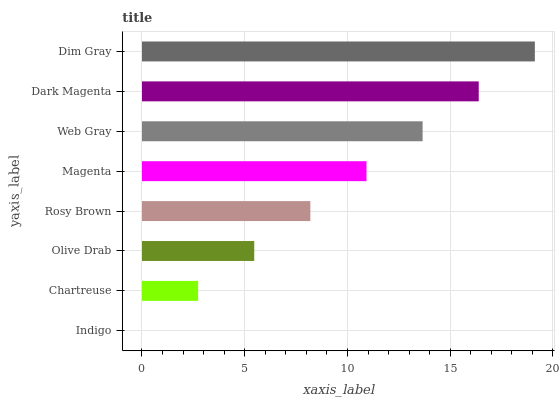Is Indigo the minimum?
Answer yes or no. Yes. Is Dim Gray the maximum?
Answer yes or no. Yes. Is Chartreuse the minimum?
Answer yes or no. No. Is Chartreuse the maximum?
Answer yes or no. No. Is Chartreuse greater than Indigo?
Answer yes or no. Yes. Is Indigo less than Chartreuse?
Answer yes or no. Yes. Is Indigo greater than Chartreuse?
Answer yes or no. No. Is Chartreuse less than Indigo?
Answer yes or no. No. Is Magenta the high median?
Answer yes or no. Yes. Is Rosy Brown the low median?
Answer yes or no. Yes. Is Chartreuse the high median?
Answer yes or no. No. Is Magenta the low median?
Answer yes or no. No. 